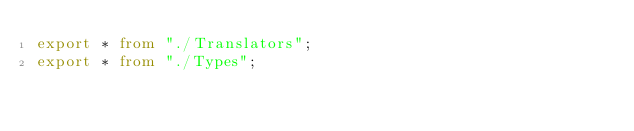<code> <loc_0><loc_0><loc_500><loc_500><_TypeScript_>export * from "./Translators";
export * from "./Types";
</code> 